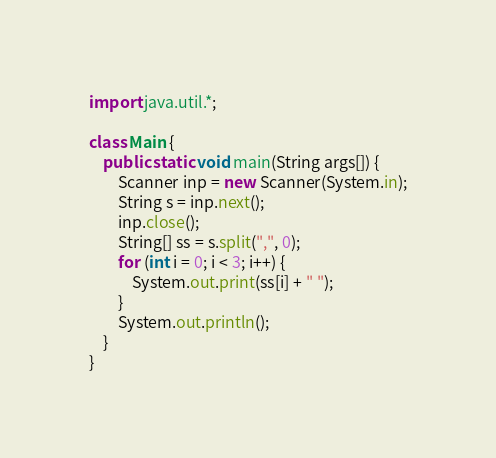Convert code to text. <code><loc_0><loc_0><loc_500><loc_500><_Java_>import java.util.*;

class Main {
    public static void main(String args[]) {
        Scanner inp = new Scanner(System.in);
        String s = inp.next();
        inp.close();
        String[] ss = s.split(",", 0);
        for (int i = 0; i < 3; i++) {
            System.out.print(ss[i] + " ");
        }
        System.out.println();
    }
}</code> 